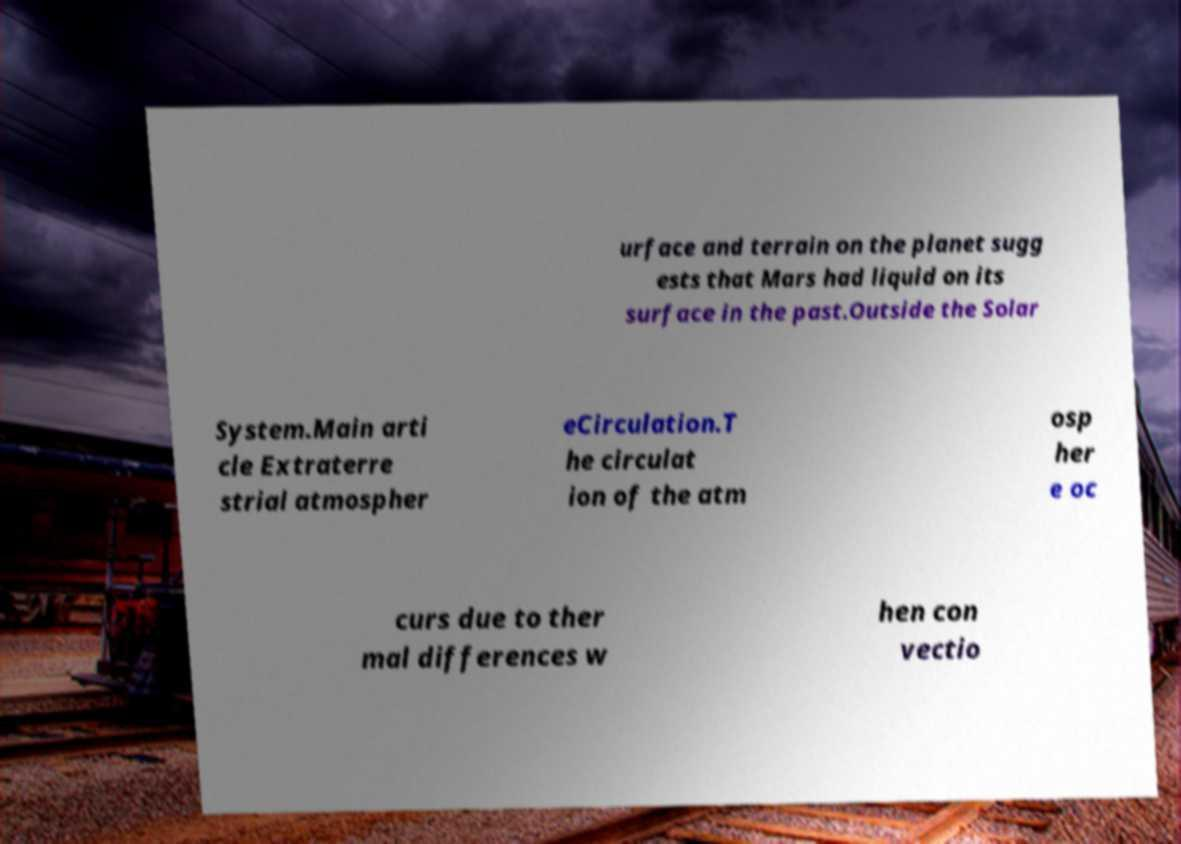Please identify and transcribe the text found in this image. urface and terrain on the planet sugg ests that Mars had liquid on its surface in the past.Outside the Solar System.Main arti cle Extraterre strial atmospher eCirculation.T he circulat ion of the atm osp her e oc curs due to ther mal differences w hen con vectio 